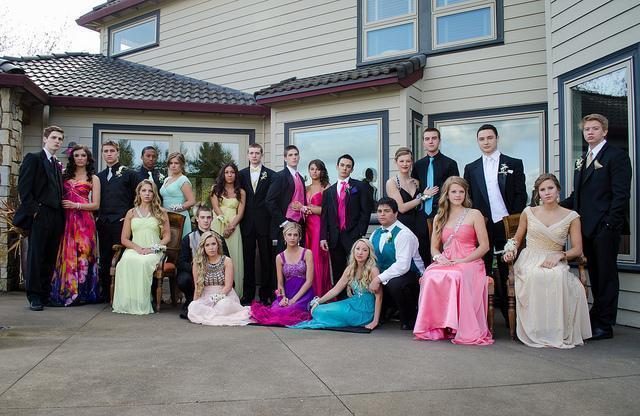Why is everyone posed so ornately?
Select the correct answer and articulate reasoning with the following format: 'Answer: answer
Rationale: rationale.'
Options: School pictures, bus stop, dinner waiting, wedding photo. Answer: wedding photo.
Rationale: The people are visibly wearing formal attire. when wearing formal attired and posing in such a manner, they may be attending an event similar to answer a. 